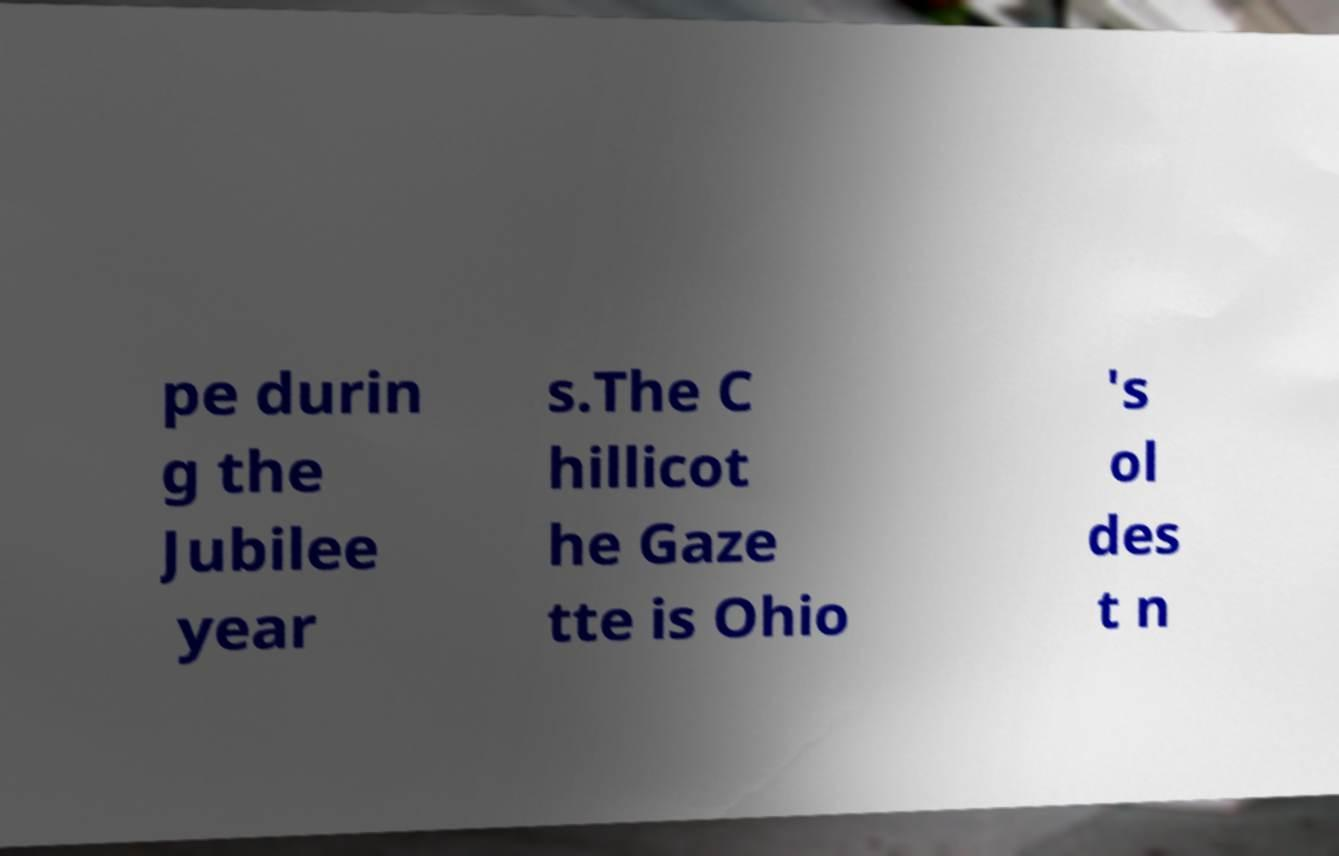Please identify and transcribe the text found in this image. pe durin g the Jubilee year s.The C hillicot he Gaze tte is Ohio 's ol des t n 